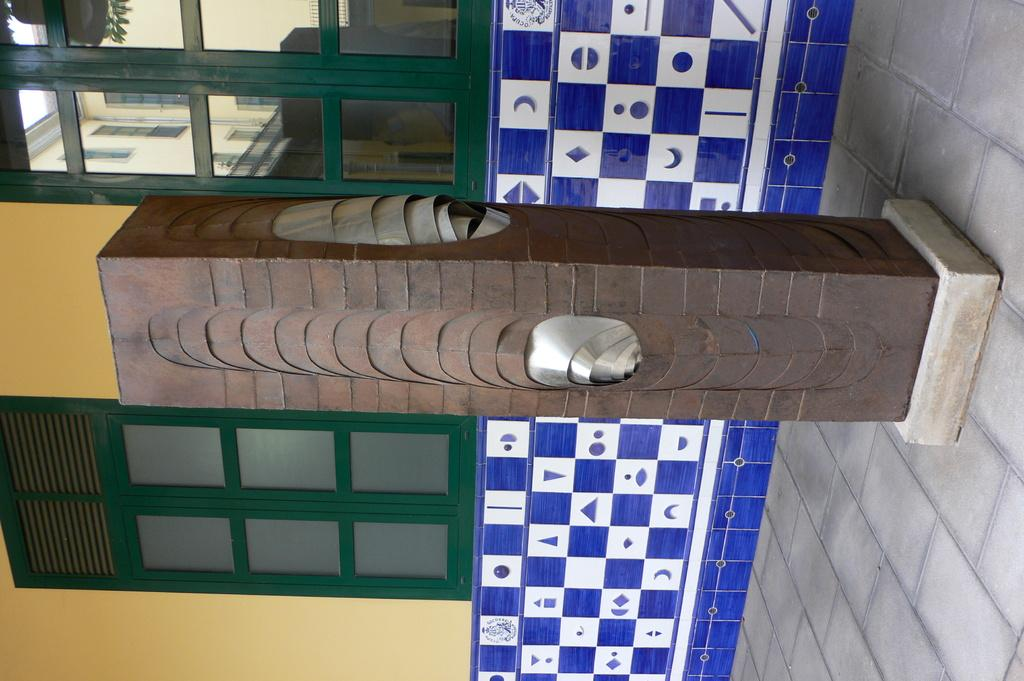What structure is the main subject of the image? There is a well in the image. What material is used for the windows of the well? The windows of the well are made of glass. What architectural element can be seen in the image? There is a pillar in the image. What type of holiday is being celebrated in the image? There is no indication of a holiday being celebrated in the image; it features a well with glass windows and a pillar. What is the slope of the ground in the image? There is no slope visible in the image; it appears to be a flat surface. 